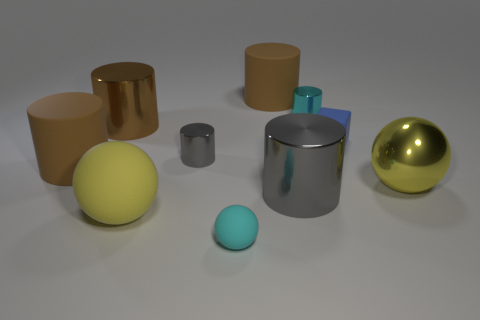How many yellow objects are either cylinders or big matte spheres?
Give a very brief answer. 1. There is a rubber cylinder on the left side of the brown matte cylinder that is to the right of the large rubber sphere; is there a brown matte thing behind it?
Ensure brevity in your answer.  Yes. The big metal object that is the same color as the big rubber ball is what shape?
Offer a terse response. Sphere. Is there any other thing that has the same material as the cube?
Give a very brief answer. Yes. How many large things are brown things or matte things?
Provide a short and direct response. 4. Does the tiny rubber object that is in front of the tiny matte cube have the same shape as the large yellow metallic object?
Provide a succinct answer. Yes. Are there fewer matte cubes than purple spheres?
Keep it short and to the point. No. Is there any other thing of the same color as the large metal sphere?
Provide a short and direct response. Yes. What shape is the small metal object that is left of the cyan matte ball?
Your response must be concise. Cylinder. There is a small matte block; is its color the same as the small cylinder in front of the brown shiny cylinder?
Keep it short and to the point. No. 